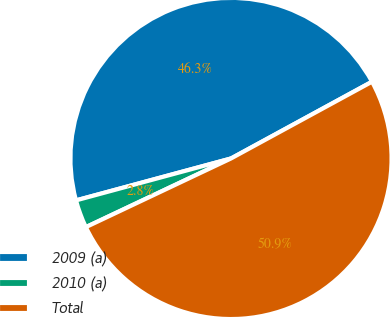Convert chart to OTSL. <chart><loc_0><loc_0><loc_500><loc_500><pie_chart><fcel>2009 (a)<fcel>2010 (a)<fcel>Total<nl><fcel>46.27%<fcel>2.83%<fcel>50.9%<nl></chart> 